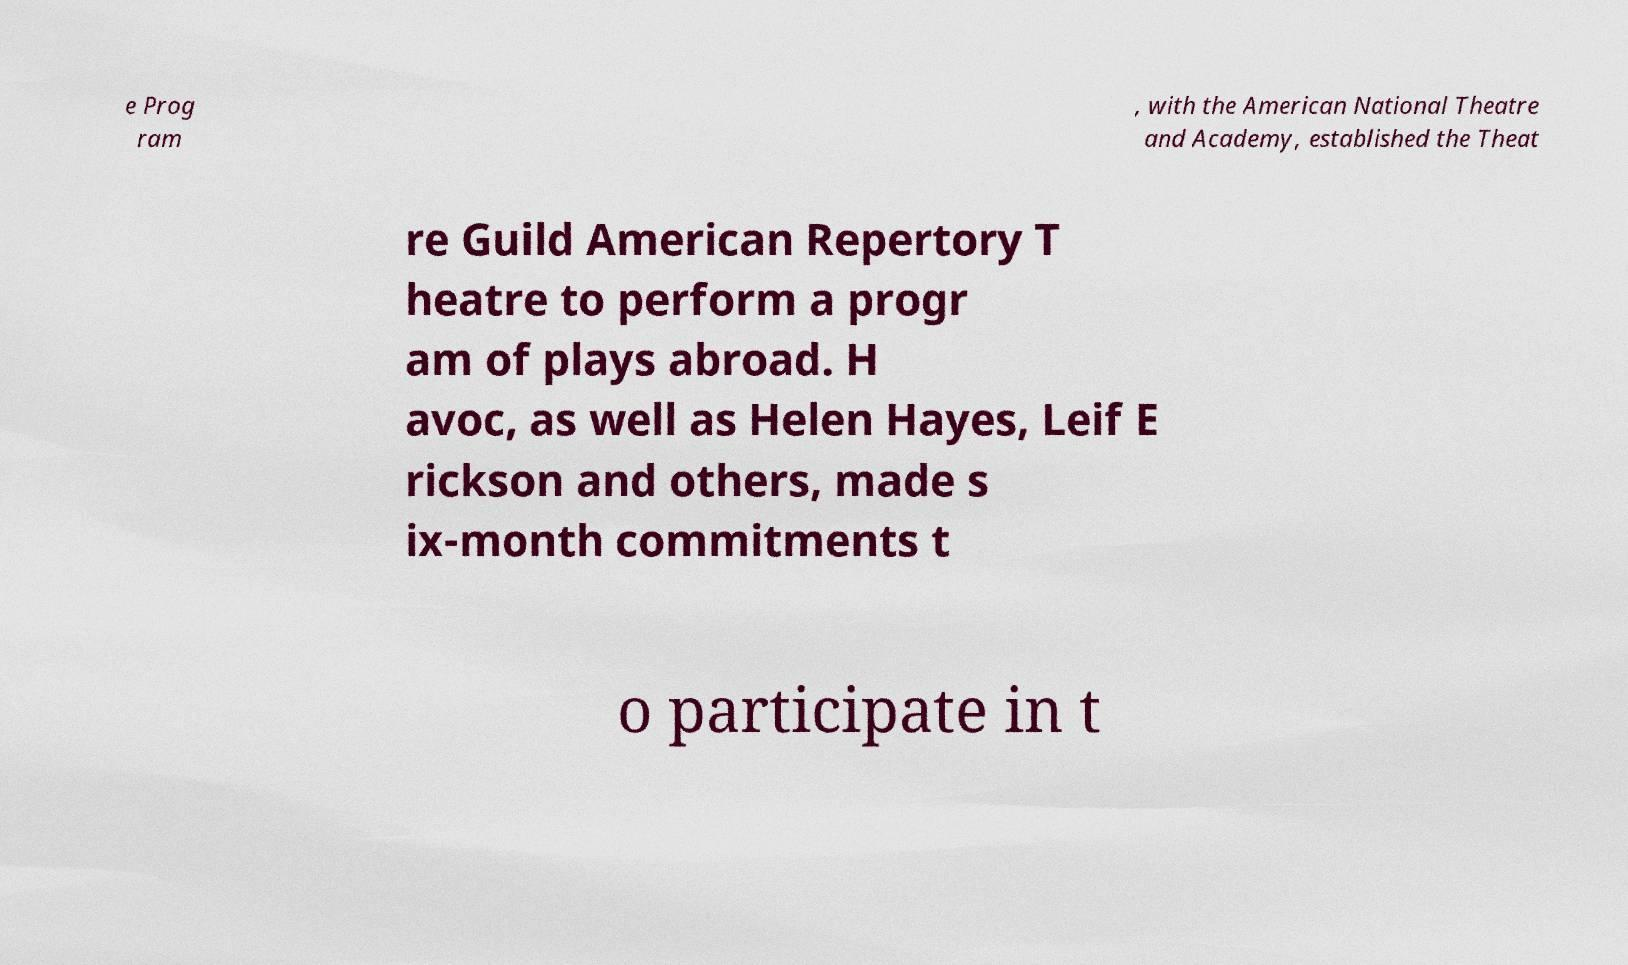Could you assist in decoding the text presented in this image and type it out clearly? e Prog ram , with the American National Theatre and Academy, established the Theat re Guild American Repertory T heatre to perform a progr am of plays abroad. H avoc, as well as Helen Hayes, Leif E rickson and others, made s ix-month commitments t o participate in t 